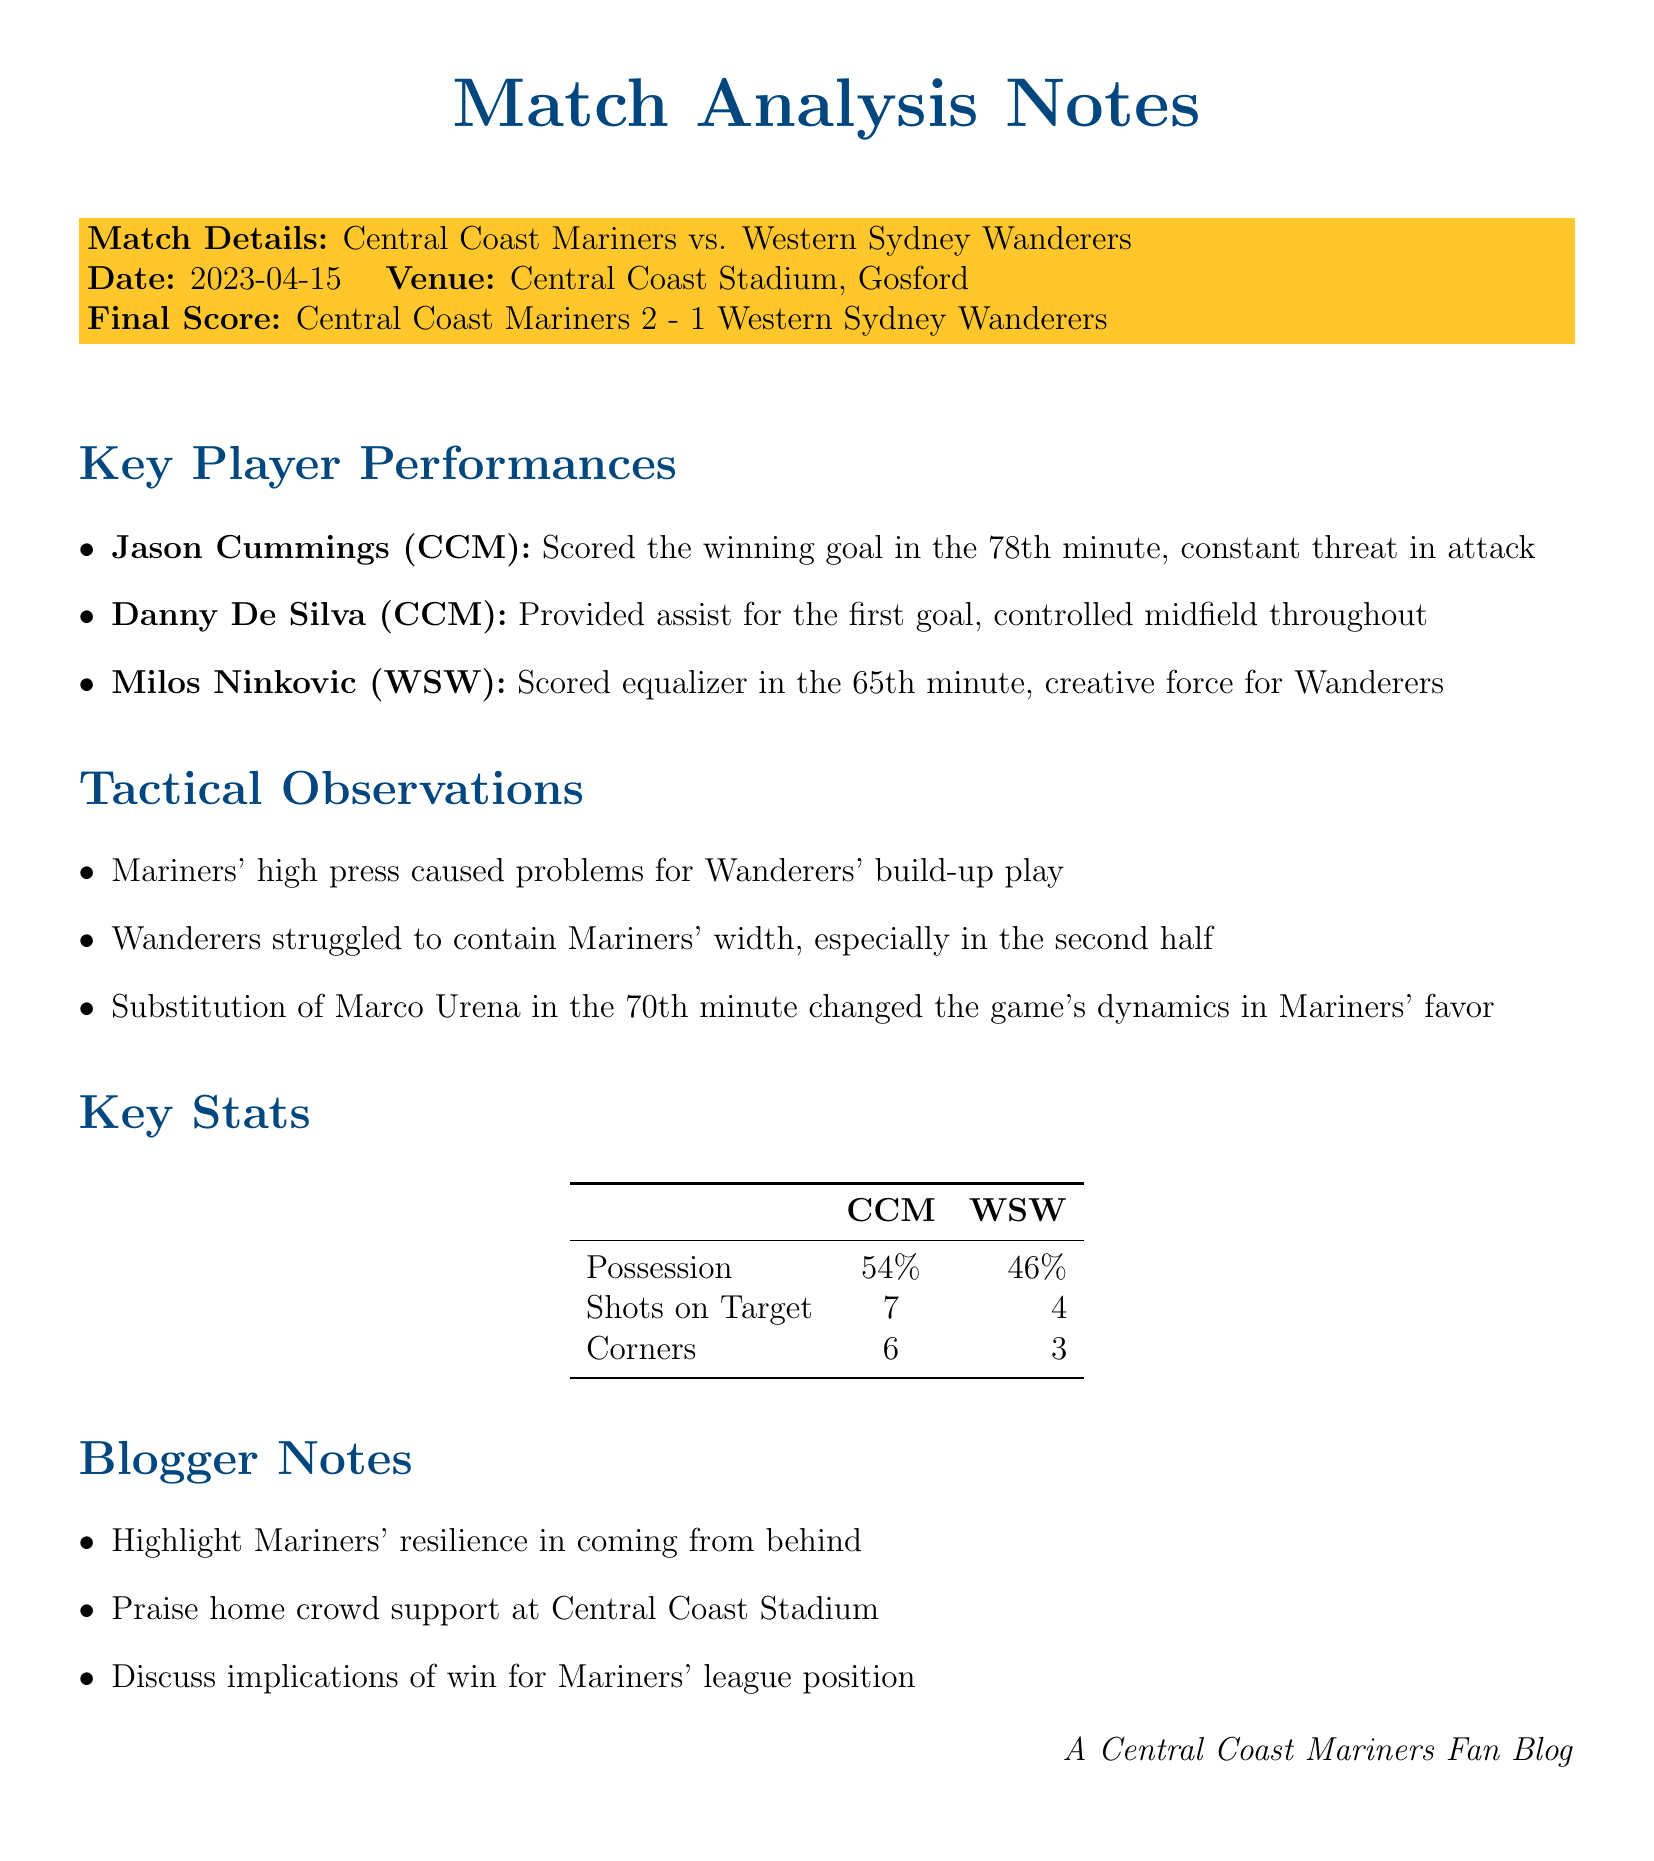What was the final score of the match? The final score of the match is reported in the match details section.
Answer: Central Coast Mariners 2 - 1 Western Sydney Wanderers Who scored the winning goal for the Mariners? The document lists key player performances which include who scored goals.
Answer: Jason Cummings What minute did Milos Ninkovic score? The performance details of key players include the specific times of their goals.
Answer: 65th minute How many shots on target did the Mariners have? Key stats include shot counts for both teams.
Answer: 7 In which minute was Marco Urena substituted? The tactical observations provide information about player substitutions and their timings.
Answer: 70th minute What was the possession percentage for the Mariners? Key stats section provides specific possession percentages for both teams.
Answer: 54% What is one tactical observation mentioned about the Mariners? The tactical observations provide insights on game strategies used by the teams.
Answer: Mariners' high press caused problems for Wanderers' build-up play Which player provided the assist for the first goal? Key player performances specify contributions for each player.
Answer: Danny De Silva What does the blogger note highlight about the Mariners? The blogger notes summarize important aspects of the match.
Answer: Resilience in coming from behind 